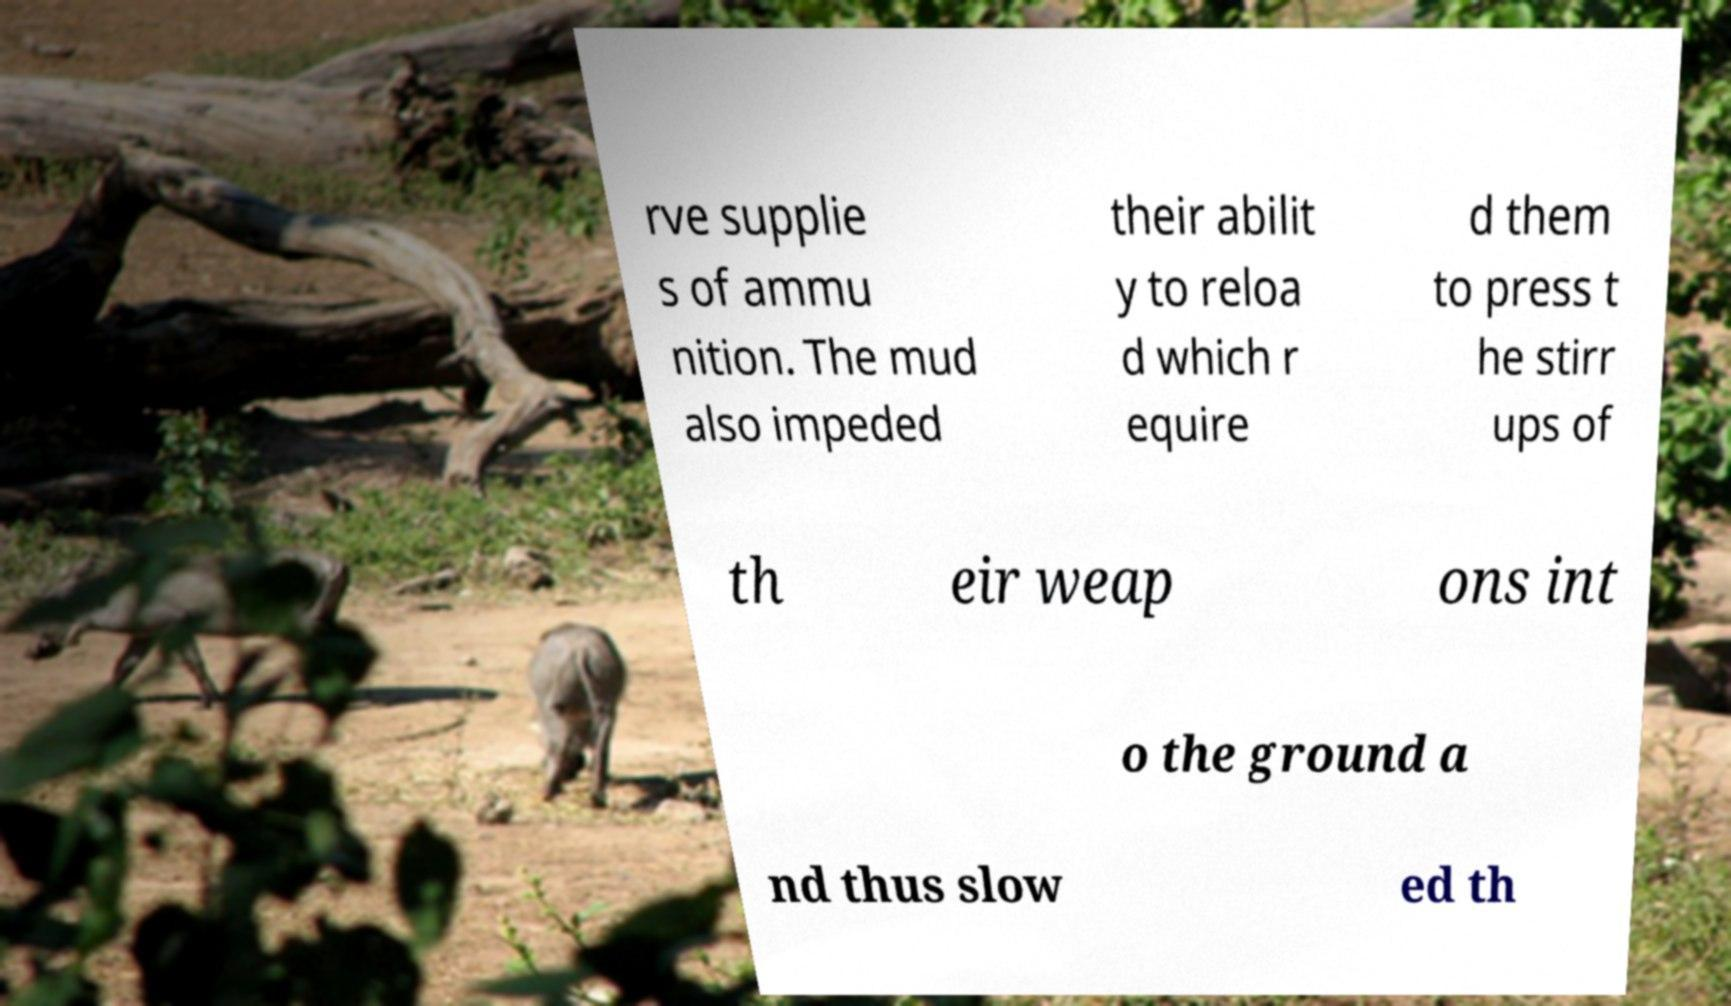Please read and relay the text visible in this image. What does it say? rve supplie s of ammu nition. The mud also impeded their abilit y to reloa d which r equire d them to press t he stirr ups of th eir weap ons int o the ground a nd thus slow ed th 